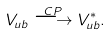Convert formula to latex. <formula><loc_0><loc_0><loc_500><loc_500>V _ { u b } \stackrel { C P } { \longrightarrow } V _ { u b } ^ { \ast } .</formula> 